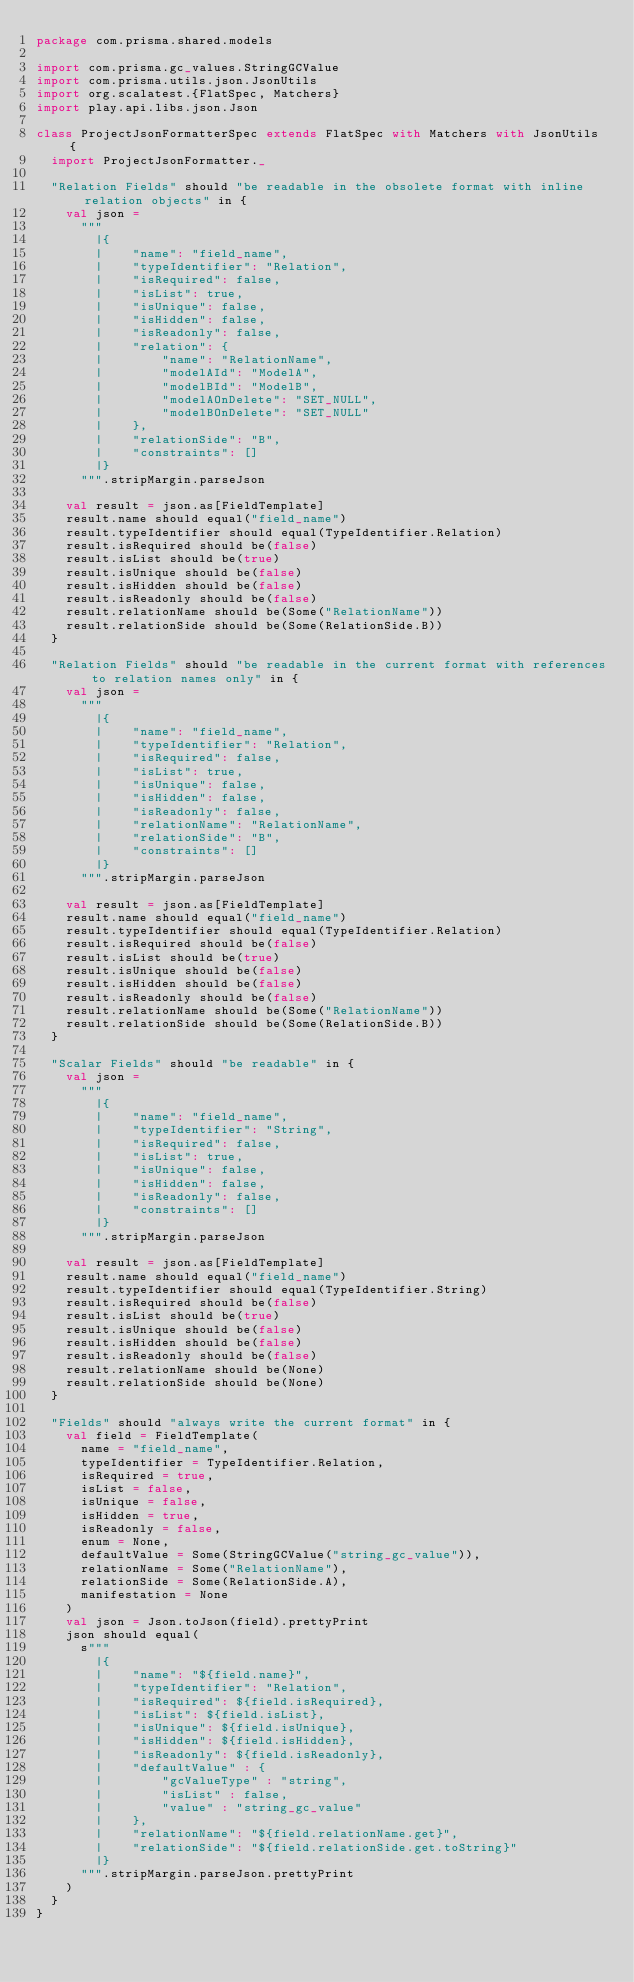<code> <loc_0><loc_0><loc_500><loc_500><_Scala_>package com.prisma.shared.models

import com.prisma.gc_values.StringGCValue
import com.prisma.utils.json.JsonUtils
import org.scalatest.{FlatSpec, Matchers}
import play.api.libs.json.Json

class ProjectJsonFormatterSpec extends FlatSpec with Matchers with JsonUtils {
  import ProjectJsonFormatter._

  "Relation Fields" should "be readable in the obsolete format with inline relation objects" in {
    val json =
      """
        |{
        |    "name": "field_name",
        |    "typeIdentifier": "Relation",
        |    "isRequired": false,
        |    "isList": true,
        |    "isUnique": false,
        |    "isHidden": false,
        |    "isReadonly": false,
        |    "relation": {
        |        "name": "RelationName",
        |        "modelAId": "ModelA",
        |        "modelBId": "ModelB",
        |        "modelAOnDelete": "SET_NULL",
        |        "modelBOnDelete": "SET_NULL"
        |    },
        |    "relationSide": "B",
        |    "constraints": []
        |}
      """.stripMargin.parseJson

    val result = json.as[FieldTemplate]
    result.name should equal("field_name")
    result.typeIdentifier should equal(TypeIdentifier.Relation)
    result.isRequired should be(false)
    result.isList should be(true)
    result.isUnique should be(false)
    result.isHidden should be(false)
    result.isReadonly should be(false)
    result.relationName should be(Some("RelationName"))
    result.relationSide should be(Some(RelationSide.B))
  }

  "Relation Fields" should "be readable in the current format with references to relation names only" in {
    val json =
      """
        |{
        |    "name": "field_name",
        |    "typeIdentifier": "Relation",
        |    "isRequired": false,
        |    "isList": true,
        |    "isUnique": false,
        |    "isHidden": false,
        |    "isReadonly": false,
        |    "relationName": "RelationName",
        |    "relationSide": "B",
        |    "constraints": []
        |}
      """.stripMargin.parseJson

    val result = json.as[FieldTemplate]
    result.name should equal("field_name")
    result.typeIdentifier should equal(TypeIdentifier.Relation)
    result.isRequired should be(false)
    result.isList should be(true)
    result.isUnique should be(false)
    result.isHidden should be(false)
    result.isReadonly should be(false)
    result.relationName should be(Some("RelationName"))
    result.relationSide should be(Some(RelationSide.B))
  }

  "Scalar Fields" should "be readable" in {
    val json =
      """
        |{
        |    "name": "field_name",
        |    "typeIdentifier": "String",
        |    "isRequired": false,
        |    "isList": true,
        |    "isUnique": false,
        |    "isHidden": false,
        |    "isReadonly": false,
        |    "constraints": []
        |}
      """.stripMargin.parseJson

    val result = json.as[FieldTemplate]
    result.name should equal("field_name")
    result.typeIdentifier should equal(TypeIdentifier.String)
    result.isRequired should be(false)
    result.isList should be(true)
    result.isUnique should be(false)
    result.isHidden should be(false)
    result.isReadonly should be(false)
    result.relationName should be(None)
    result.relationSide should be(None)
  }

  "Fields" should "always write the current format" in {
    val field = FieldTemplate(
      name = "field_name",
      typeIdentifier = TypeIdentifier.Relation,
      isRequired = true,
      isList = false,
      isUnique = false,
      isHidden = true,
      isReadonly = false,
      enum = None,
      defaultValue = Some(StringGCValue("string_gc_value")),
      relationName = Some("RelationName"),
      relationSide = Some(RelationSide.A),
      manifestation = None
    )
    val json = Json.toJson(field).prettyPrint
    json should equal(
      s"""
        |{
        |    "name": "${field.name}",
        |    "typeIdentifier": "Relation",
        |    "isRequired": ${field.isRequired},
        |    "isList": ${field.isList},
        |    "isUnique": ${field.isUnique},
        |    "isHidden": ${field.isHidden},
        |    "isReadonly": ${field.isReadonly},
        |    "defaultValue" : {
        |        "gcValueType" : "string",
        |        "isList" : false,
        |        "value" : "string_gc_value"
        |    },
        |    "relationName": "${field.relationName.get}",
        |    "relationSide": "${field.relationSide.get.toString}"
        |}
      """.stripMargin.parseJson.prettyPrint
    )
  }
}
</code> 